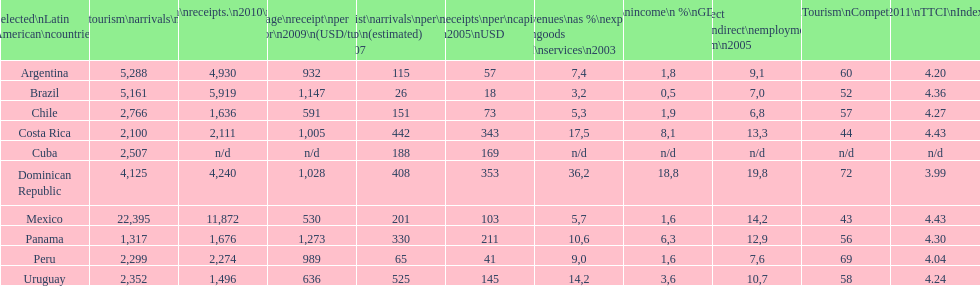What country ranks the best in most categories? Dominican Republic. 